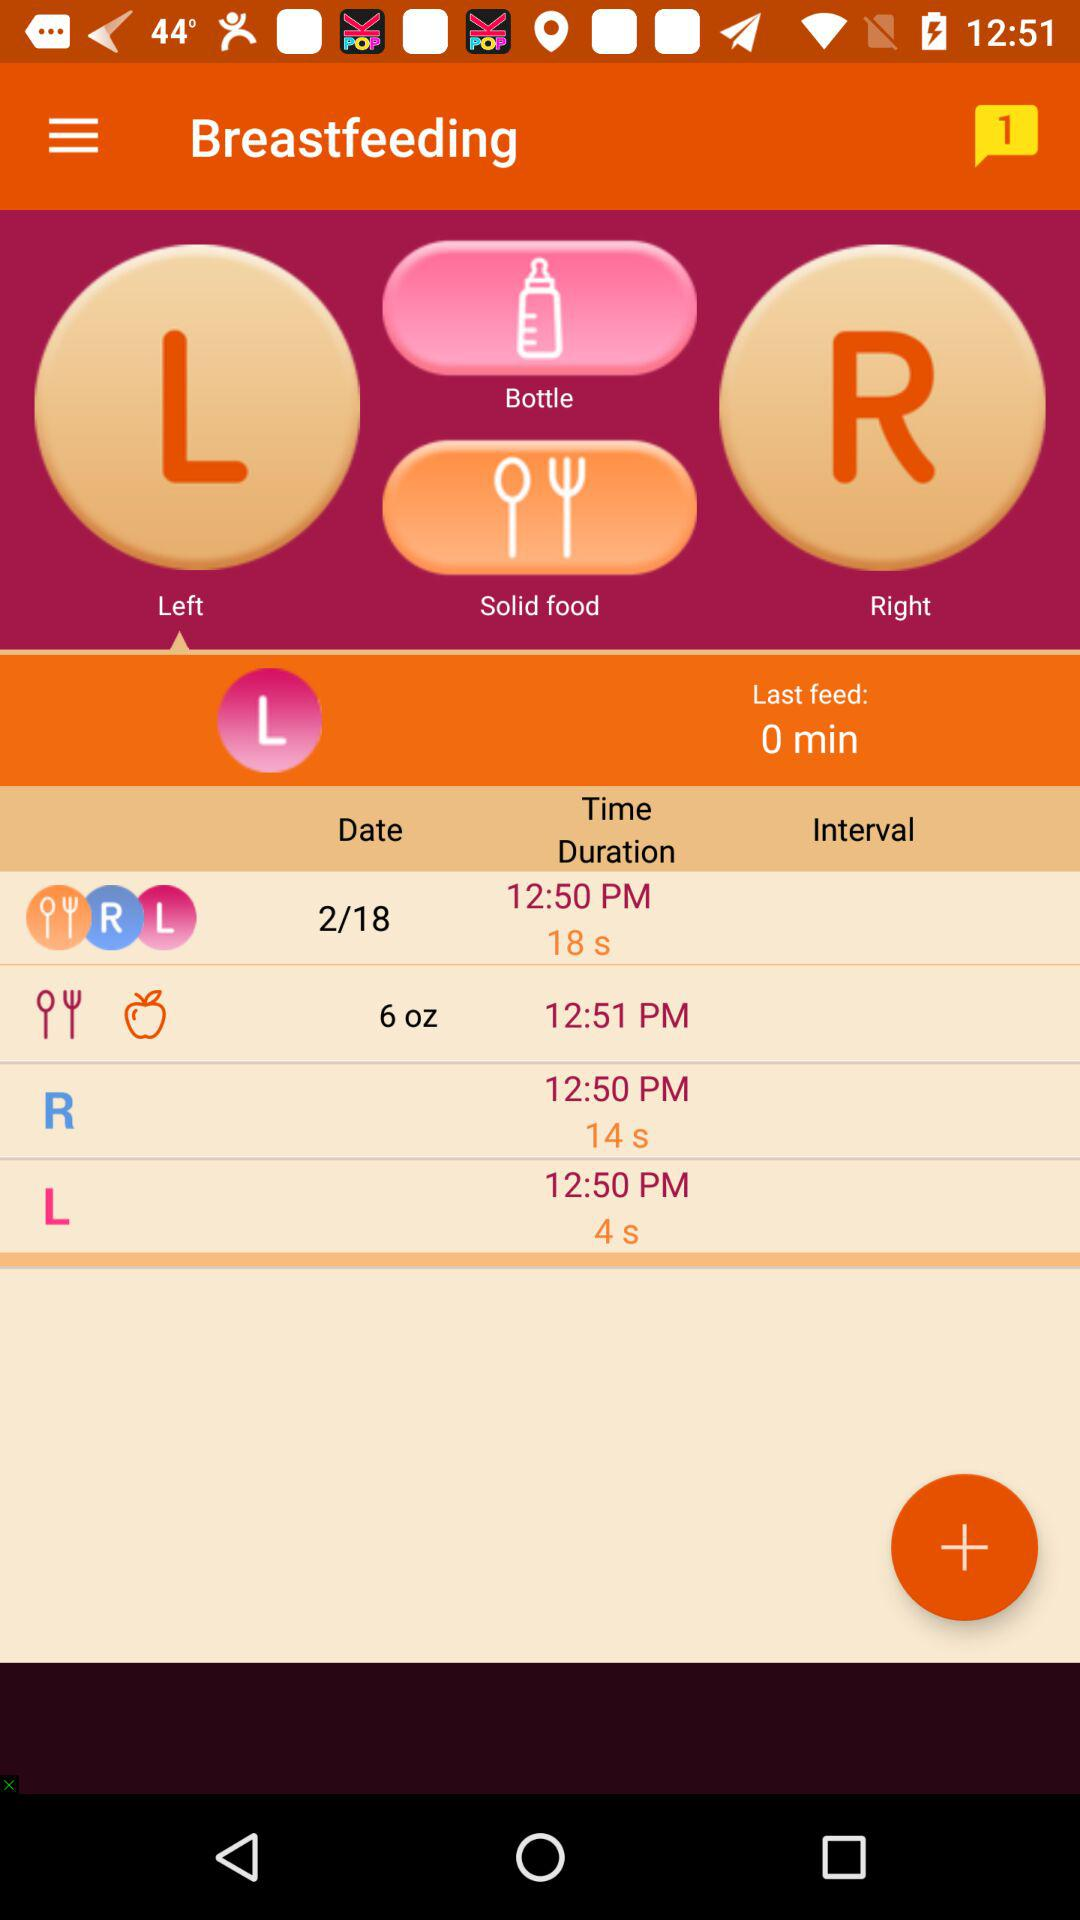What date is shown? The shown date is February 18. 